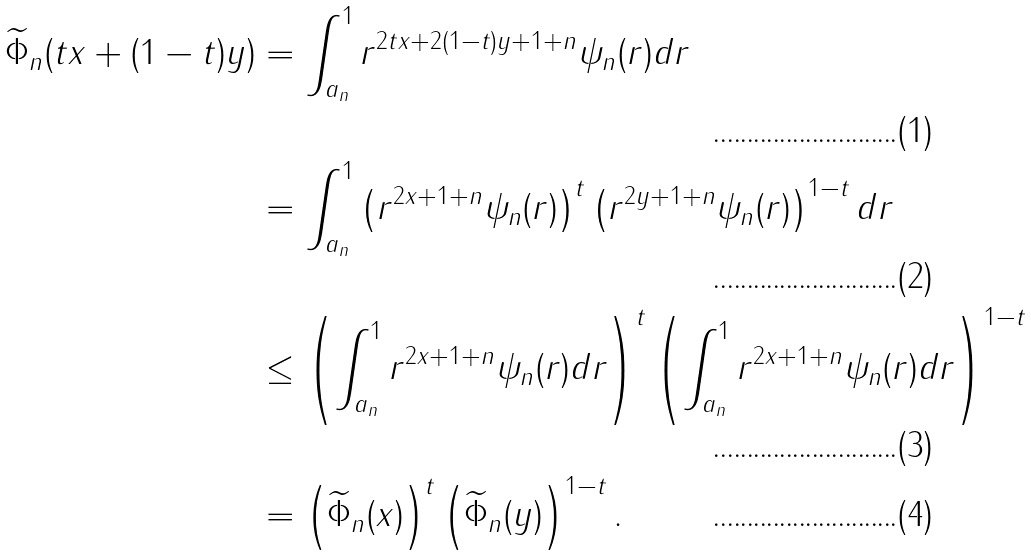Convert formula to latex. <formula><loc_0><loc_0><loc_500><loc_500>\widetilde { \Phi } _ { n } ( t x + ( 1 - t ) y ) & = \int _ { a _ { n } } ^ { 1 } r ^ { 2 t x + 2 ( 1 - t ) y + 1 + n } \psi _ { n } ( r ) d r \\ & = \int _ { a _ { n } } ^ { 1 } \left ( r ^ { 2 x + 1 + n } \psi _ { n } ( r ) \right ) ^ { t } \left ( r ^ { 2 y + 1 + n } \psi _ { n } ( r ) \right ) ^ { 1 - t } d r \\ & \leq \left ( \int _ { a _ { n } } ^ { 1 } r ^ { 2 x + 1 + n } \psi _ { n } ( r ) d r \right ) ^ { t } \left ( \int _ { a _ { n } } ^ { 1 } r ^ { 2 x + 1 + n } \psi _ { n } ( r ) d r \right ) ^ { 1 - t } \\ & = \left ( \widetilde { \Phi } _ { n } ( x ) \right ) ^ { t } \left ( \widetilde { \Phi } _ { n } ( y ) \right ) ^ { 1 - t } .</formula> 